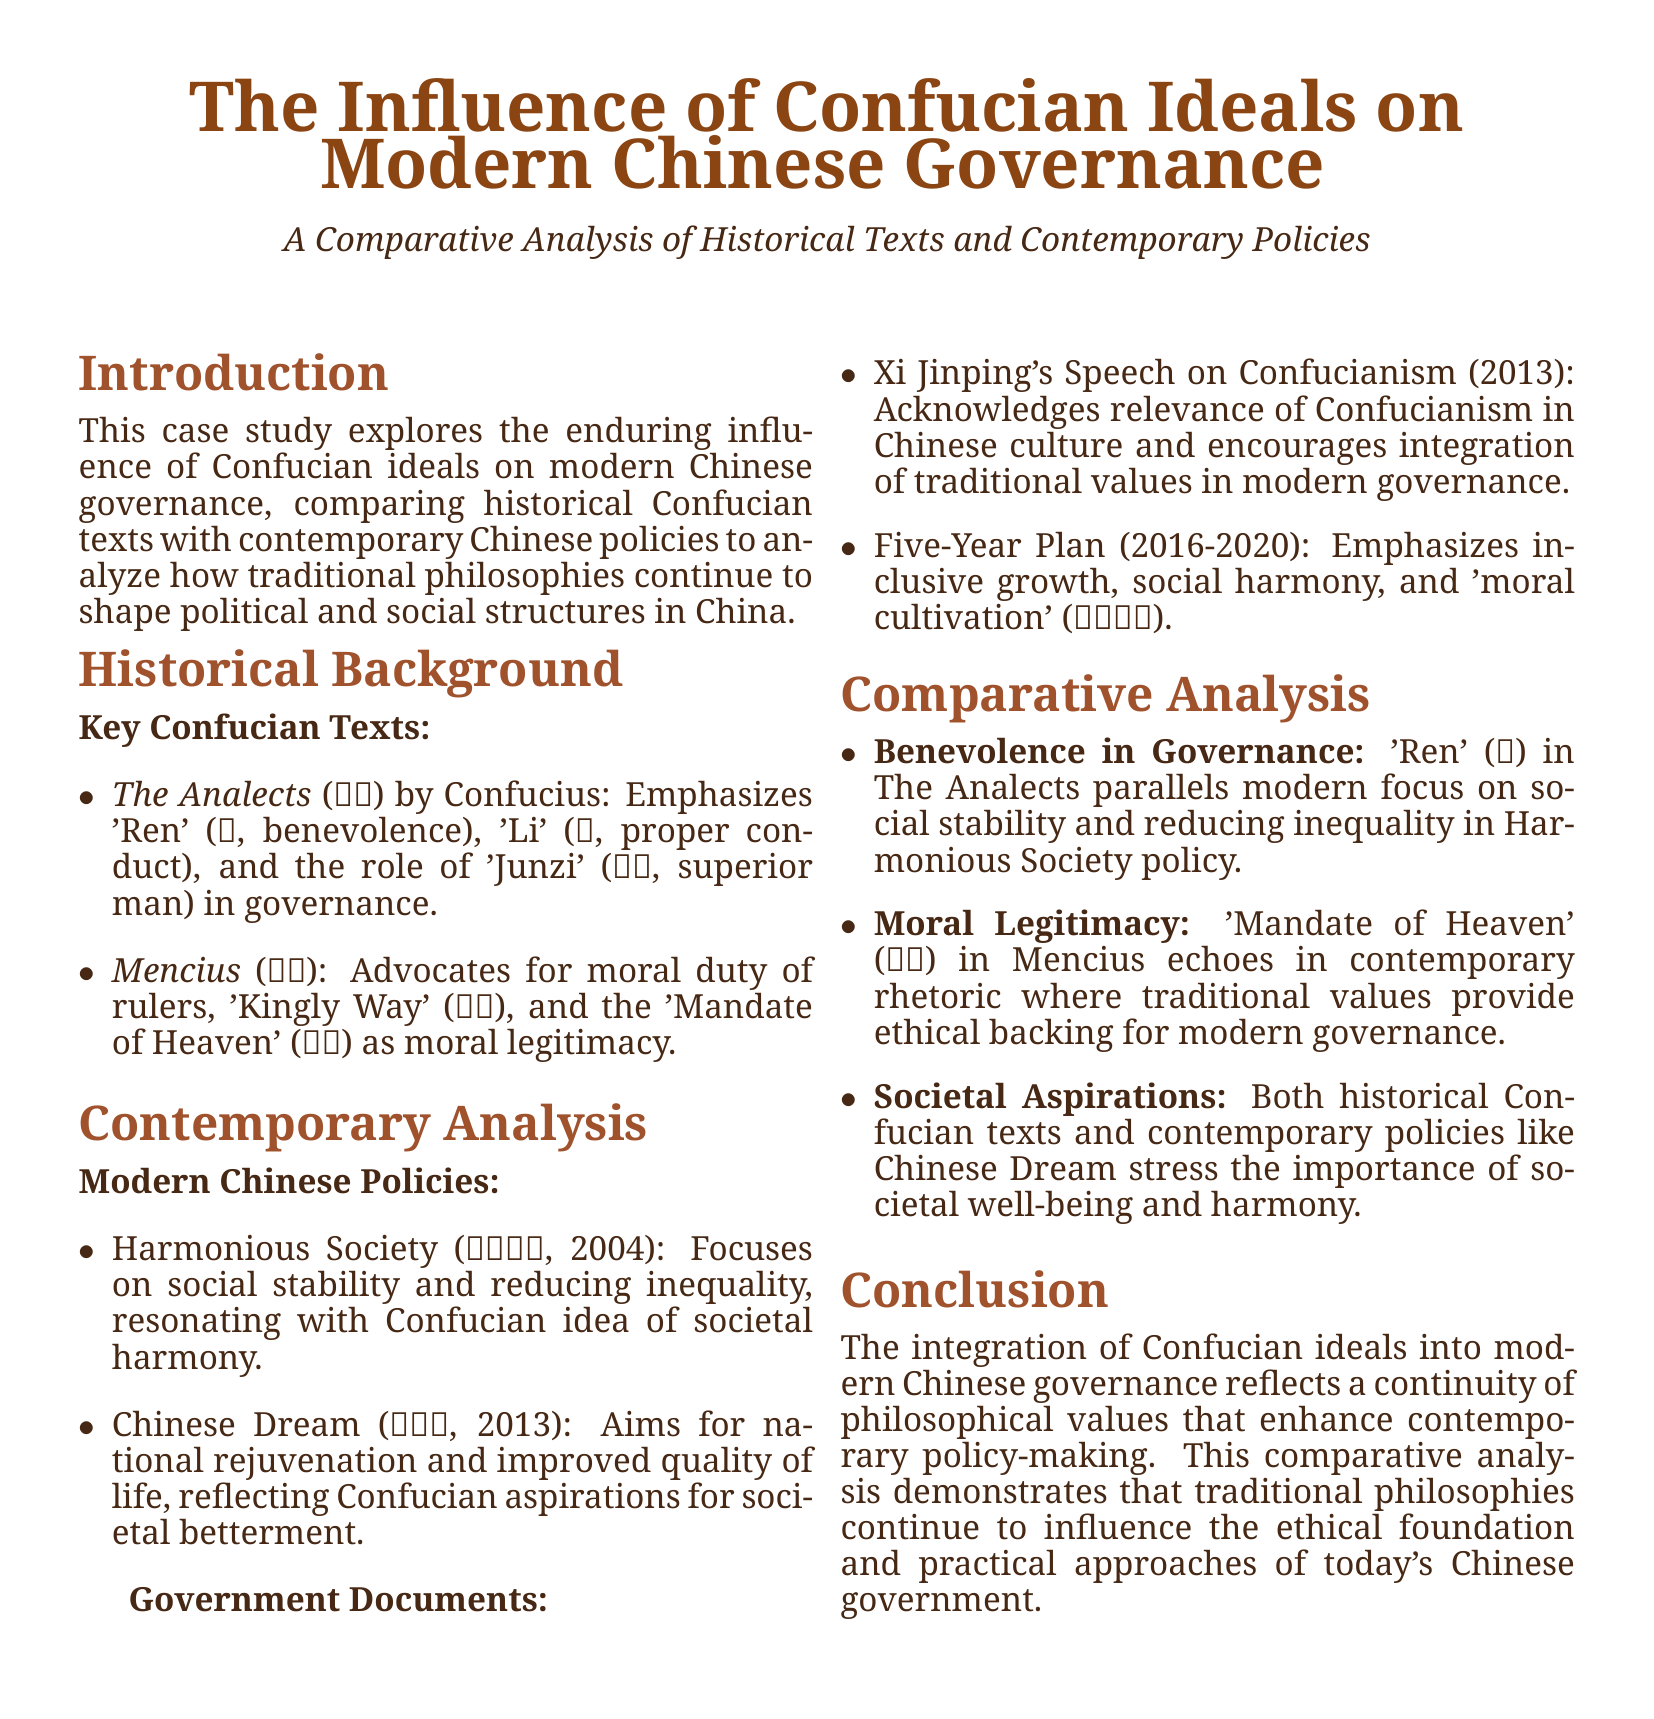What are the key Confucian texts mentioned? The document lists two key texts: \textit{The Analects} by Confucius and \textit{Mencius}.
Answer: The Analects, Mencius What is the main focus of the Harmonious Society policy? The document states that Harmonious Society focuses on social stability and reducing inequality.
Answer: Social stability and reducing inequality What concept from Mencius emphasizes moral duty of rulers? The document identifies the 'Kingly Way' as the concept that advocates for the moral duty of rulers.
Answer: King's Way What year was the Chinese Dream introduced? The document notes that the Chinese Dream was introduced in 2013.
Answer: 2013 Which Confucian value is paralleled with the modern focus on social stability? The document mentions that 'Ren' (benevolence) in The Analects parallels with the focus on social stability.
Answer: Ren What does the Five-Year Plan emphasize? According to the document, the Five-Year Plan emphasizes inclusive growth, social harmony, and moral cultivation.
Answer: Inclusive growth, social harmony, moral cultivation Who delivered a speech acknowledging the relevance of Confucianism in modern governance? The document states that Xi Jinping delivered a speech on Confucianism in 2013.
Answer: Xi Jinping How do both historical texts and contemporary policies stress societal aspirations? The document explains that both highlight the importance of societal well-being and harmony.
Answer: Societal well-being and harmony What is the title of the case study? The document states the title is "The Influence of Confucian Ideals on Modern Chinese Governance."
Answer: The Influence of Confucian Ideals on Modern Chinese Governance 